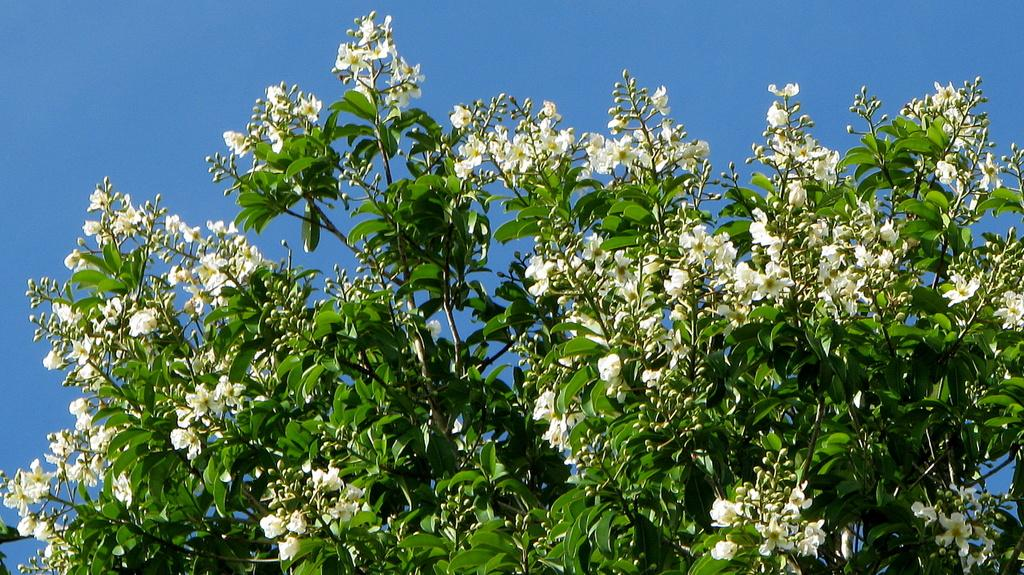What is the main subject of the image? The main subject of the image is a tree. What can be observed about the tree in the image? The tree has flowers and buds. What is visible in the background of the image? The sky is visible in the background of the image. How many nests can be seen in the tree in the image? There are no nests visible in the image; it only shows a tree with flowers and buds. What type of house is located near the tree in the image? There is no house present in the image; it only shows a tree with flowers and buds. 